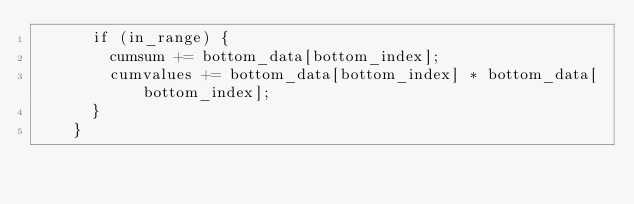<code> <loc_0><loc_0><loc_500><loc_500><_Cuda_>      if (in_range) {
        cumsum += bottom_data[bottom_index];
        cumvalues += bottom_data[bottom_index] * bottom_data[bottom_index];
      }
    }</code> 